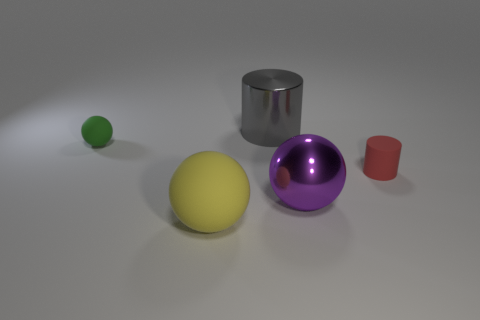What size is the cylinder that is made of the same material as the yellow ball?
Ensure brevity in your answer.  Small. Is the number of things less than the number of large blue shiny objects?
Your answer should be very brief. No. What number of big objects are either metallic things or yellow things?
Provide a short and direct response. 3. How many rubber things are both in front of the red thing and behind the yellow rubber sphere?
Your response must be concise. 0. Is the number of red things greater than the number of big brown objects?
Offer a very short reply. Yes. What number of other objects are there of the same shape as the red matte thing?
Ensure brevity in your answer.  1. Is the color of the large metallic cylinder the same as the large rubber ball?
Make the answer very short. No. What material is the object that is in front of the tiny green ball and behind the purple object?
Your answer should be very brief. Rubber. The yellow object has what size?
Your answer should be very brief. Large. There is a big thing behind the cylinder in front of the small ball; how many purple metallic spheres are in front of it?
Keep it short and to the point. 1. 